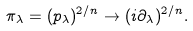<formula> <loc_0><loc_0><loc_500><loc_500>\pi _ { \lambda } = ( p _ { \lambda } ) ^ { 2 / n } \rightarrow ( i \partial _ { \lambda } ) ^ { 2 / n } .</formula> 